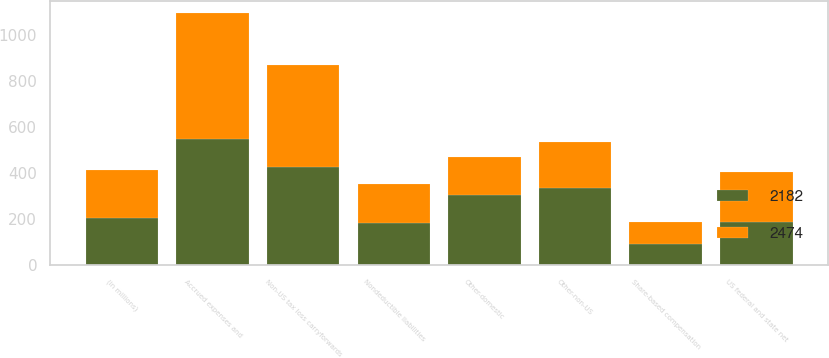Convert chart. <chart><loc_0><loc_0><loc_500><loc_500><stacked_bar_chart><ecel><fcel>(in millions)<fcel>Accrued expenses and<fcel>US federal and state net<fcel>Share-based compensation<fcel>Nondeductible liabilities<fcel>Non-US tax loss carryforwards<fcel>Other-domestic<fcel>Other-non-US<nl><fcel>2182<fcel>207<fcel>551<fcel>190<fcel>91<fcel>184<fcel>426<fcel>306<fcel>337<nl><fcel>2474<fcel>207<fcel>544<fcel>216<fcel>97<fcel>169<fcel>445<fcel>167<fcel>198<nl></chart> 